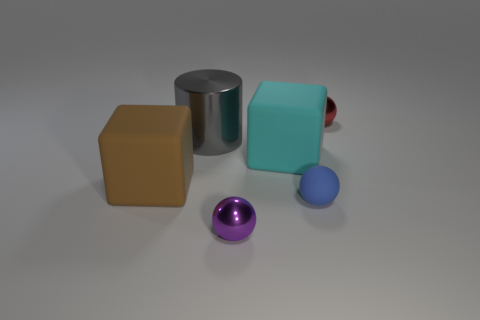Add 2 brown matte cubes. How many objects exist? 8 Subtract all cyan blocks. How many blocks are left? 1 Subtract all metallic balls. How many balls are left? 1 Subtract all blocks. How many objects are left? 4 Subtract 2 cubes. How many cubes are left? 0 Subtract all blue cylinders. Subtract all green balls. How many cylinders are left? 1 Subtract all gray cubes. How many red balls are left? 1 Subtract all large yellow metallic objects. Subtract all purple things. How many objects are left? 5 Add 5 gray shiny cylinders. How many gray shiny cylinders are left? 6 Add 3 blue things. How many blue things exist? 4 